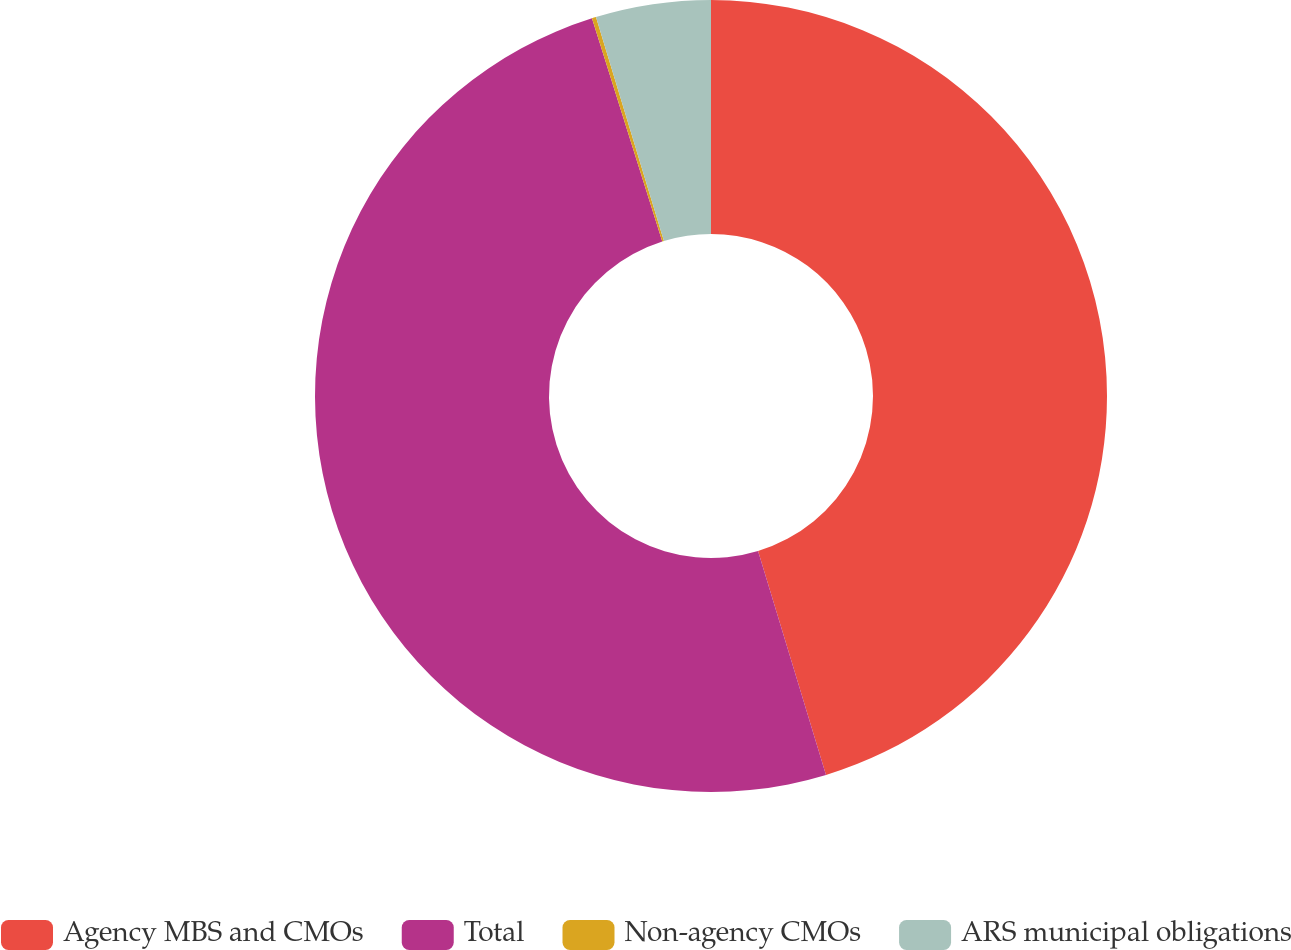Convert chart. <chart><loc_0><loc_0><loc_500><loc_500><pie_chart><fcel>Agency MBS and CMOs<fcel>Total<fcel>Non-agency CMOs<fcel>ARS municipal obligations<nl><fcel>45.31%<fcel>49.83%<fcel>0.17%<fcel>4.69%<nl></chart> 